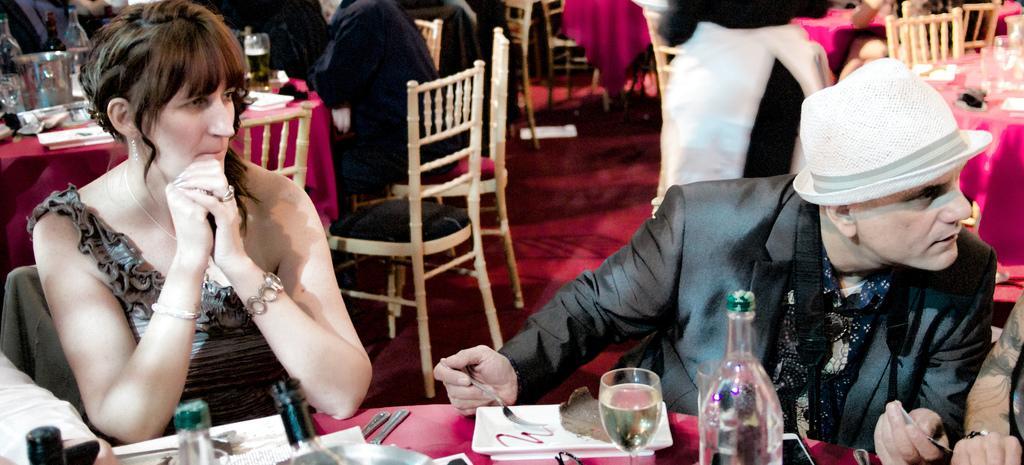In one or two sentences, can you explain what this image depicts? In this image I can see few people sitting on the chairs around the tables which are covered with pink color clothes. These are dining tables. On this tables I can see glasses, bottles, spoons, papers, bowls and some other objects. On the right side there is a man wearing suit, cap on the head and looking at the person who is beside him. On the left side there is a woman looking at the right side. 